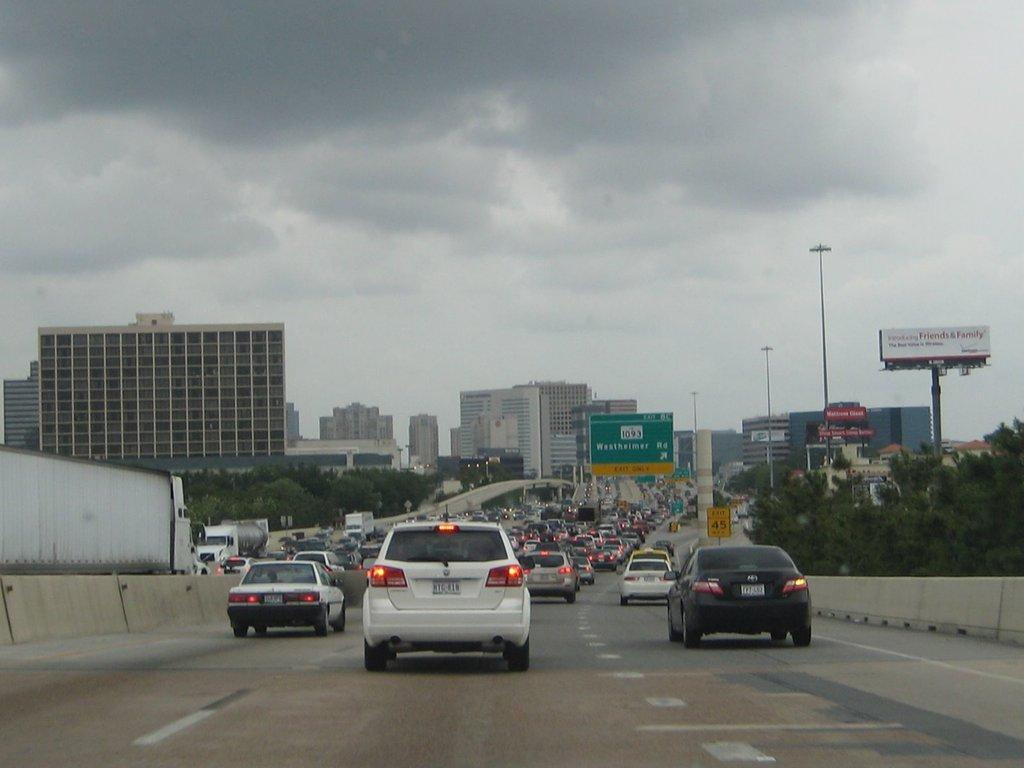What can be seen on the bridge in the image? There are cars and vehicles on the bridge in the image. What type of signs or information is present in the image? There are boards with text in the image. What structures are visible in the image? There are buildings in the image. What type of vegetation is present in the image? There are trees in the image. What type of lighting is present in the image? There are pole lights in the image. What is the condition of the sky in the image? The sky is cloudy in the image. Can you hear the rhythm of the ocean waves in the image? There is no ocean or sound of waves present in the image; it features a bridge with cars and vehicles, buildings, trees, pole lights, and a cloudy sky. 